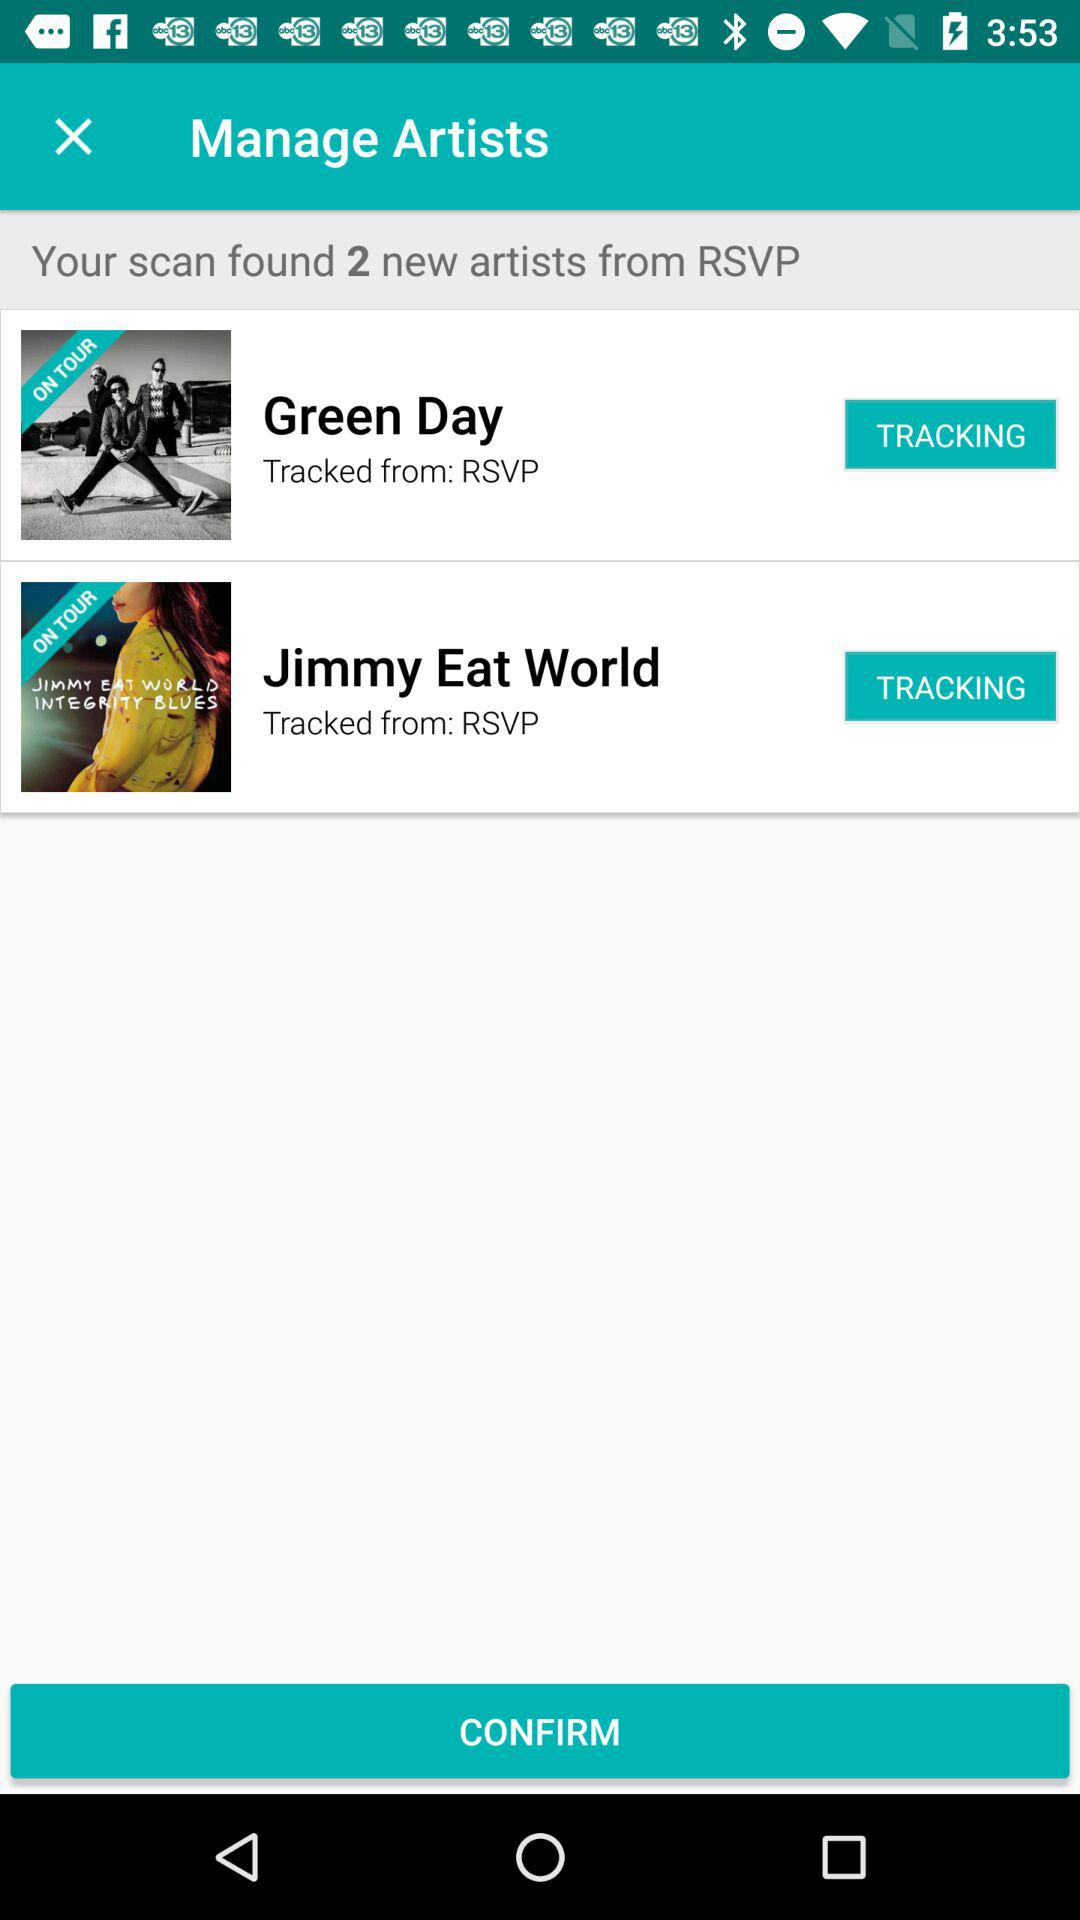Are any of the tracked artists currently on tour? Yes, according to the information shown in the image, both Green Day and Jimmy Eat World are marked as being 'ON TOUR'. This suggests that they are currently performing at various locations. 